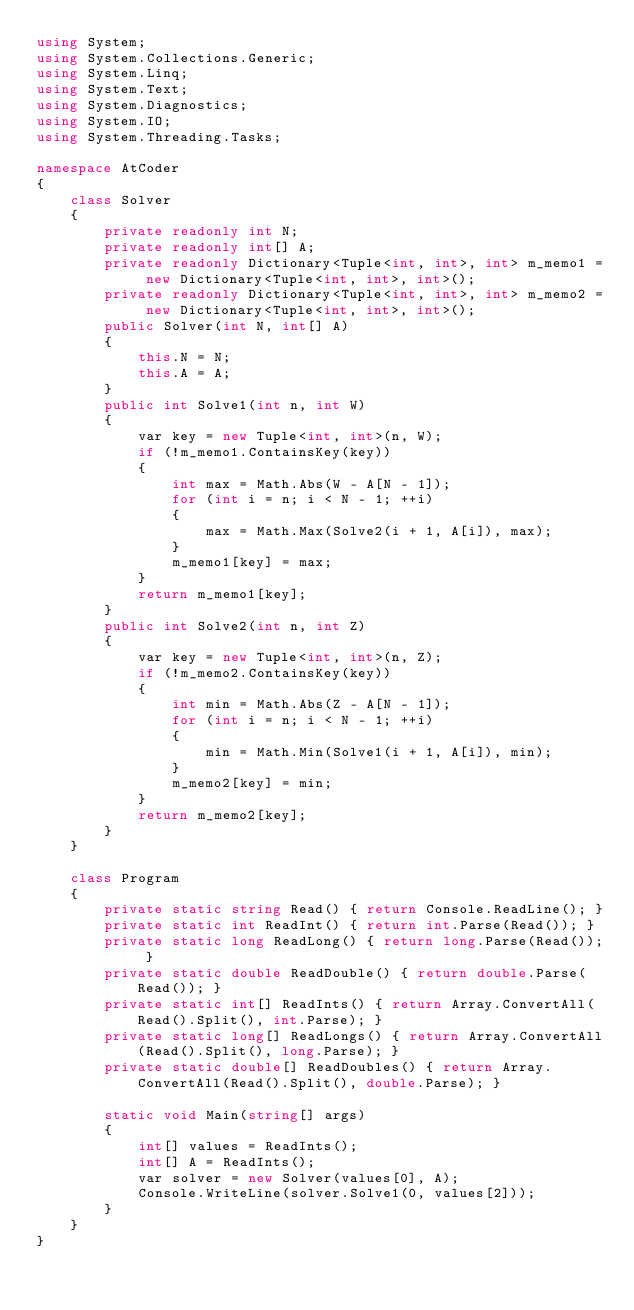<code> <loc_0><loc_0><loc_500><loc_500><_C#_>using System;
using System.Collections.Generic;
using System.Linq;
using System.Text;
using System.Diagnostics;
using System.IO;
using System.Threading.Tasks;

namespace AtCoder
{
    class Solver
    {
        private readonly int N;
        private readonly int[] A;
        private readonly Dictionary<Tuple<int, int>, int> m_memo1 = new Dictionary<Tuple<int, int>, int>();
        private readonly Dictionary<Tuple<int, int>, int> m_memo2 = new Dictionary<Tuple<int, int>, int>();
        public Solver(int N, int[] A)
        {
            this.N = N;
            this.A = A;
        }
        public int Solve1(int n, int W)
        {
            var key = new Tuple<int, int>(n, W);
            if (!m_memo1.ContainsKey(key))
            {
                int max = Math.Abs(W - A[N - 1]);
                for (int i = n; i < N - 1; ++i)
                {
                    max = Math.Max(Solve2(i + 1, A[i]), max);
                }
                m_memo1[key] = max;
            }
            return m_memo1[key];
        }
        public int Solve2(int n, int Z)
        {
            var key = new Tuple<int, int>(n, Z);
            if (!m_memo2.ContainsKey(key))
            {
                int min = Math.Abs(Z - A[N - 1]);
                for (int i = n; i < N - 1; ++i)
                {
                    min = Math.Min(Solve1(i + 1, A[i]), min);
                }
                m_memo2[key] = min;
            }
            return m_memo2[key];
        }
    }

    class Program
    {
        private static string Read() { return Console.ReadLine(); }
        private static int ReadInt() { return int.Parse(Read()); }
        private static long ReadLong() { return long.Parse(Read()); }
        private static double ReadDouble() { return double.Parse(Read()); }
        private static int[] ReadInts() { return Array.ConvertAll(Read().Split(), int.Parse); }
        private static long[] ReadLongs() { return Array.ConvertAll(Read().Split(), long.Parse); }
        private static double[] ReadDoubles() { return Array.ConvertAll(Read().Split(), double.Parse); }

        static void Main(string[] args)
        {
            int[] values = ReadInts();
            int[] A = ReadInts();
            var solver = new Solver(values[0], A);
            Console.WriteLine(solver.Solve1(0, values[2]));
        }
    }
}
</code> 